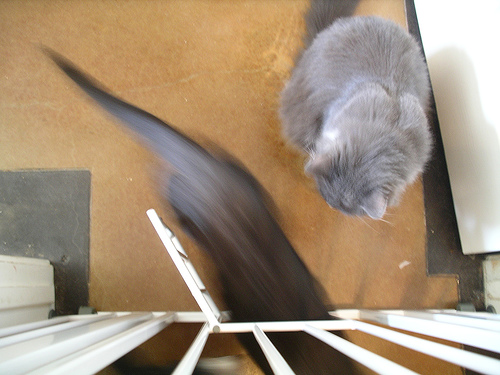<image>
Can you confirm if the cat is next to the animal? Yes. The cat is positioned adjacent to the animal, located nearby in the same general area. 